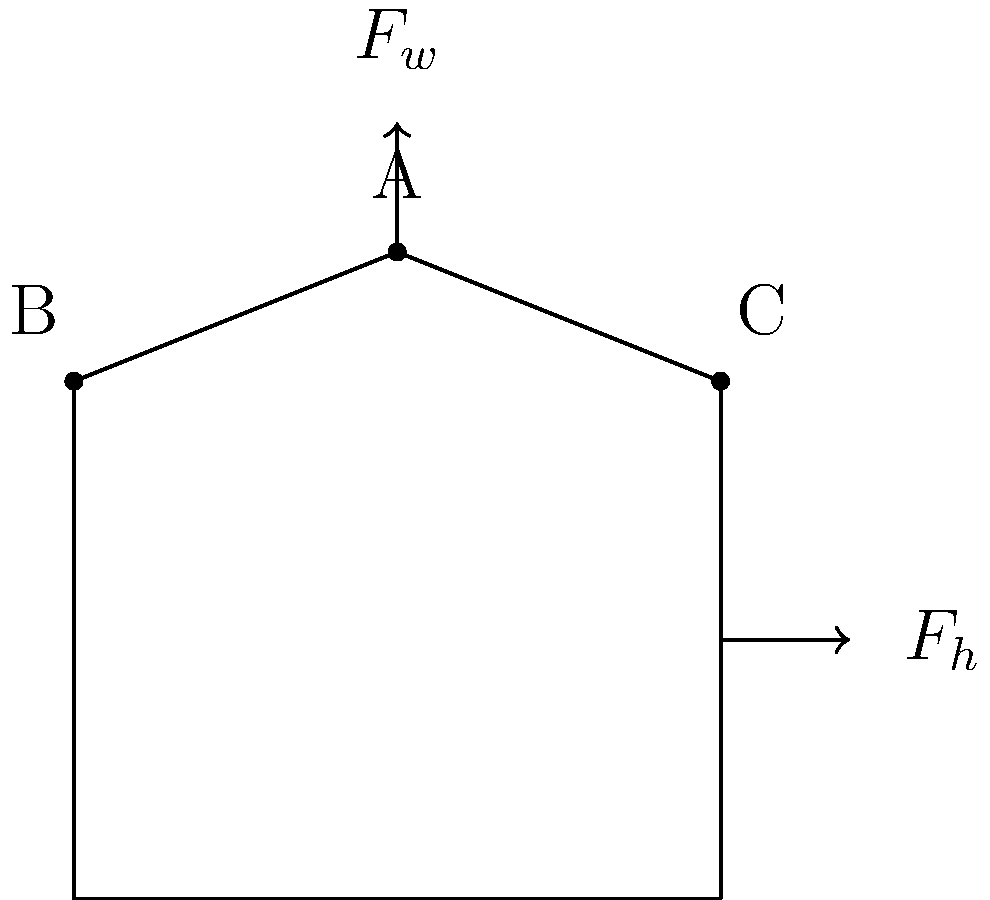In a greenhouse structure designed for lavender propagation, wind force $F_w$ acts vertically downward on the roof apex, while horizontal force $F_h$ acts on the right wall due to wind pressure. If the magnitude of $F_w$ is 5000 N and $F_h$ is 3000 N, which point (A, B, or C) experiences the highest stress concentration? To determine the point of highest stress concentration, we need to analyze the force distribution:

1. Point A (roof apex):
   - Directly experiences the vertical force $F_w$ (5000 N)
   - Acts as a junction point for the roof slopes

2. Point B (left corner):
   - Experiences a component of $F_w$ transferred through the roof
   - No direct horizontal force

3. Point C (right corner):
   - Experiences a component of $F_w$ transferred through the roof
   - Directly affected by the horizontal force $F_h$ (3000 N)

The stress concentration is highest where multiple forces converge or where there's a change in geometry. In this case:

- Point A has a high stress concentration due to the direct vertical force and being a junction point.
- Point B has some stress from the roof load but no direct forces.
- Point C experiences both vertical and horizontal forces, making it the point of highest stress concentration.

The combination of both $F_w$ and $F_h$ components at point C creates a more complex stress state than at points A or B.
Answer: Point C 